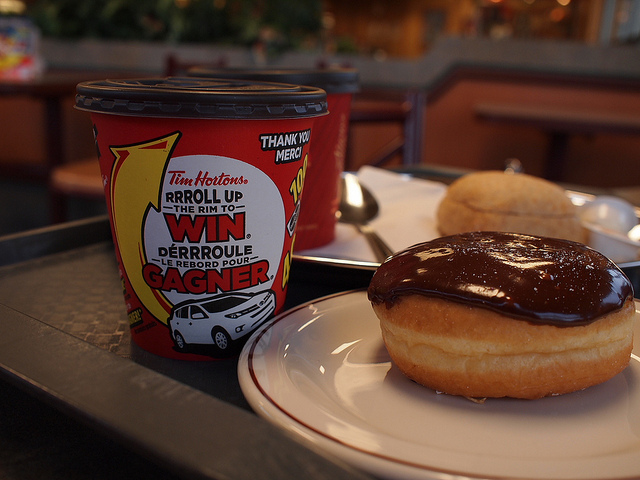<image>Where was the donut purchased? It is unknown where the donut was purchased. It could be from several places including Tim Hortons, Krispy Kreme, or Dunkin Donuts. Where was the donut purchased? The donut was purchased at Tim Hortons. 